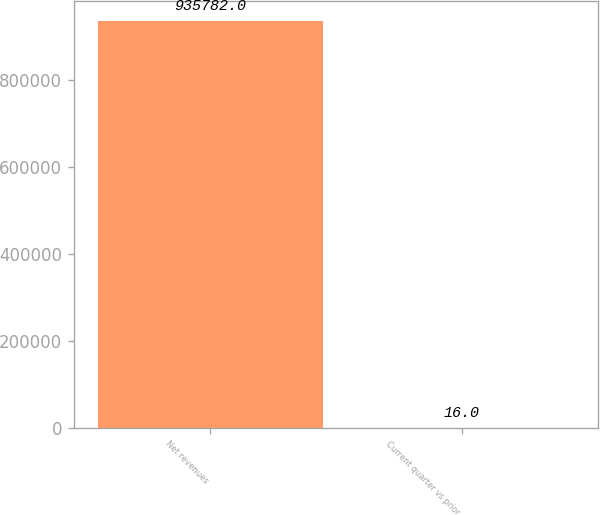Convert chart to OTSL. <chart><loc_0><loc_0><loc_500><loc_500><bar_chart><fcel>Net revenues<fcel>Current quarter vs prior<nl><fcel>935782<fcel>16<nl></chart> 